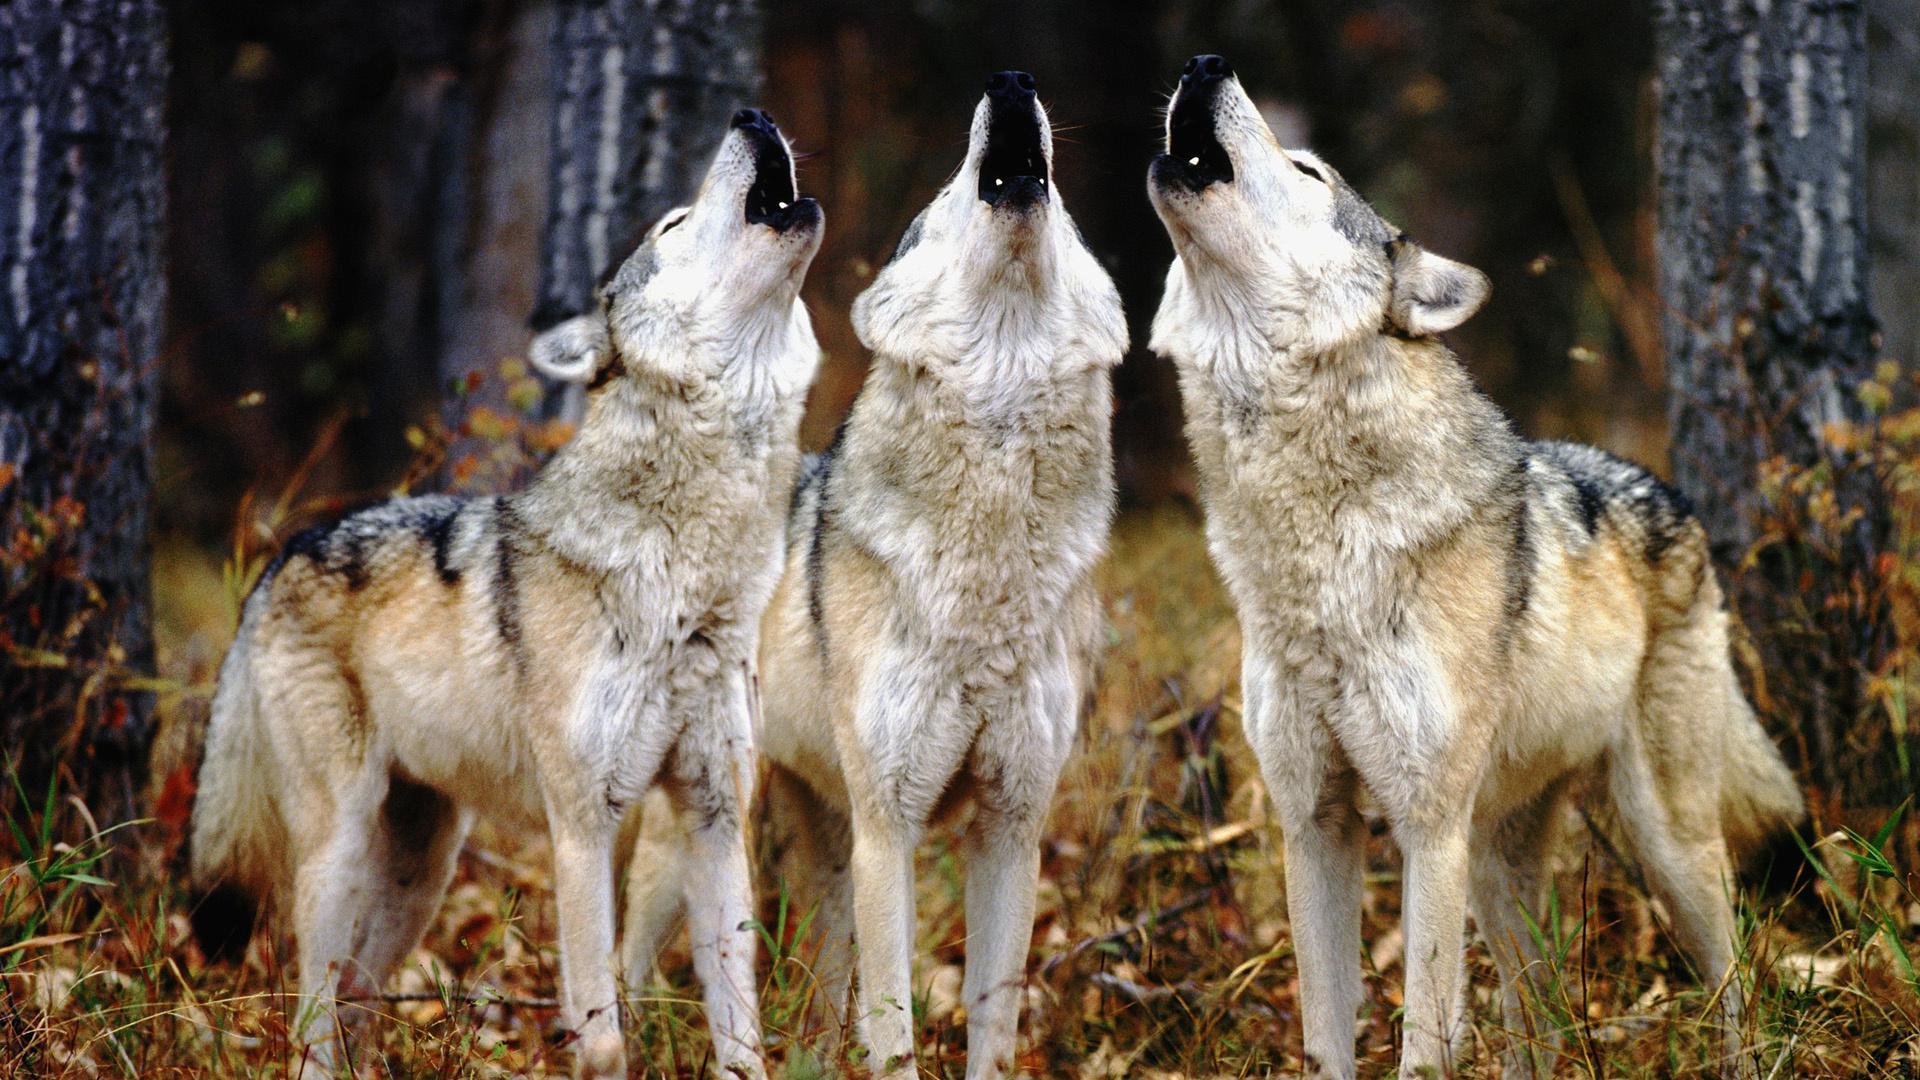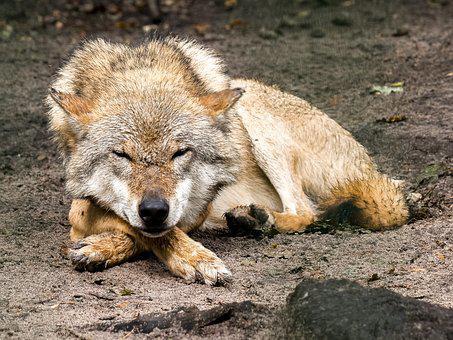The first image is the image on the left, the second image is the image on the right. Given the left and right images, does the statement "One image includes exactly twice as many wolves as the other image." hold true? Answer yes or no. No. The first image is the image on the left, the second image is the image on the right. Assess this claim about the two images: "There are three wolves". Correct or not? Answer yes or no. No. 